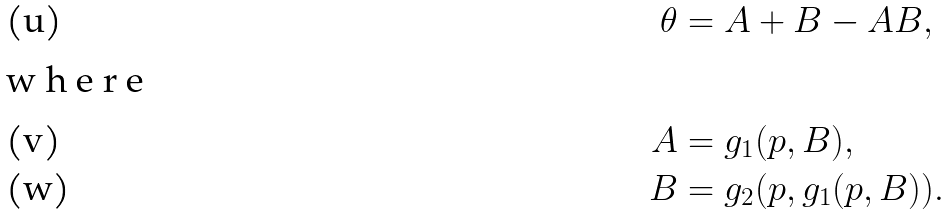Convert formula to latex. <formula><loc_0><loc_0><loc_500><loc_500>\theta & = A + B - A B , \\ \intertext { w h e r e } A & = g _ { 1 } ( p , B ) , \\ B & = g _ { 2 } ( p , g _ { 1 } ( p , B ) ) .</formula> 